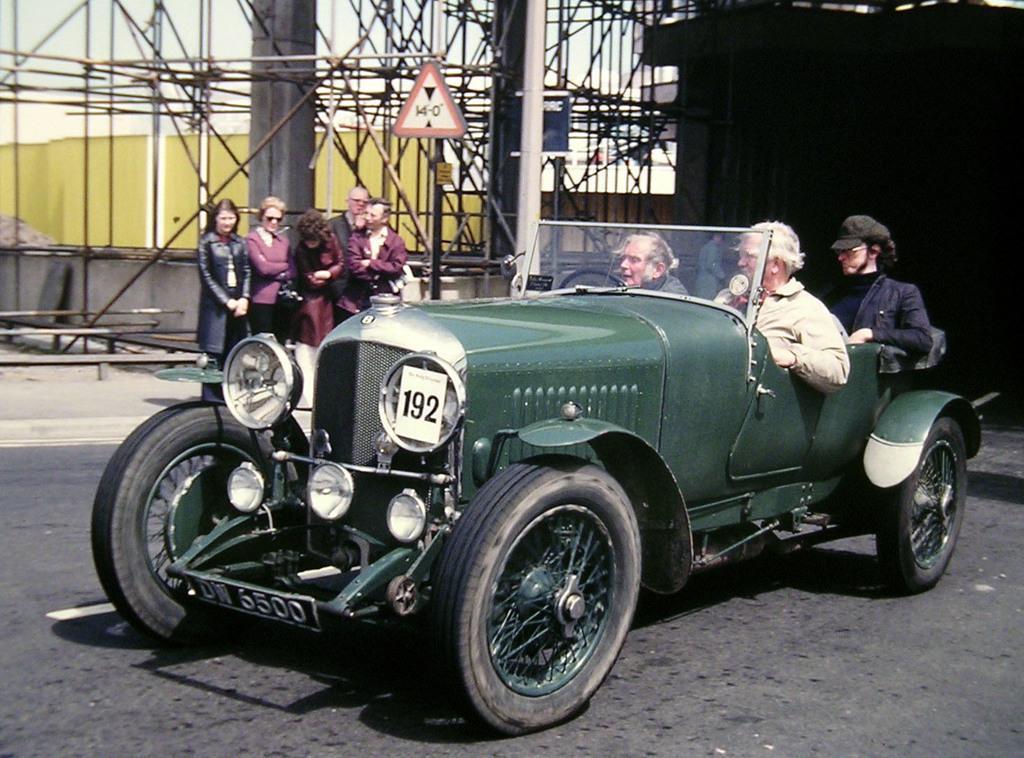Please provide a concise description of this image. In the center of the image there is a vehicle and we can see people sitting in the vehicle. In the background there is a sign board and we can see people standing. There are rods and pillars. At the bottom there is road. 